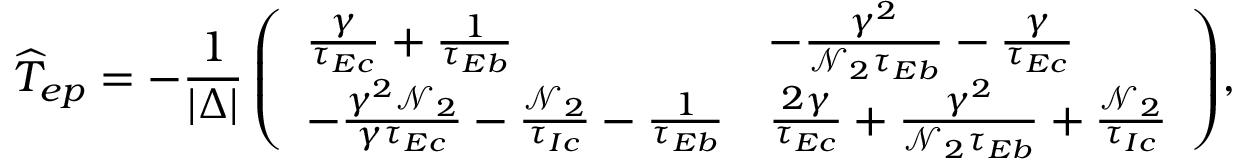<formula> <loc_0><loc_0><loc_500><loc_500>\widehat { T } _ { e p } = - \frac { 1 } { | \Delta | } \left ( \begin{array} { l l } { \frac { \gamma } { \tau _ { E c } } + \frac { 1 } { \tau _ { E b } } } & { - \frac { \gamma ^ { 2 } } { \mathcal { N } _ { 2 } \tau _ { E b } } - \frac { \gamma } { \tau _ { E c } } } \\ { - \frac { \gamma ^ { 2 } \mathcal { N } _ { 2 } } { \gamma \tau _ { E c } } - \frac { \mathcal { N } _ { 2 } } { \tau _ { I c } } - \frac { 1 } { \tau _ { E b } } } & { \frac { 2 \gamma } { \tau _ { E c } } + \frac { \gamma ^ { 2 } } { \mathcal { N } _ { 2 } \tau _ { E b } } + \frac { \mathcal { N } _ { 2 } } { \tau _ { I c } } } \end{array} \right ) \, ,</formula> 